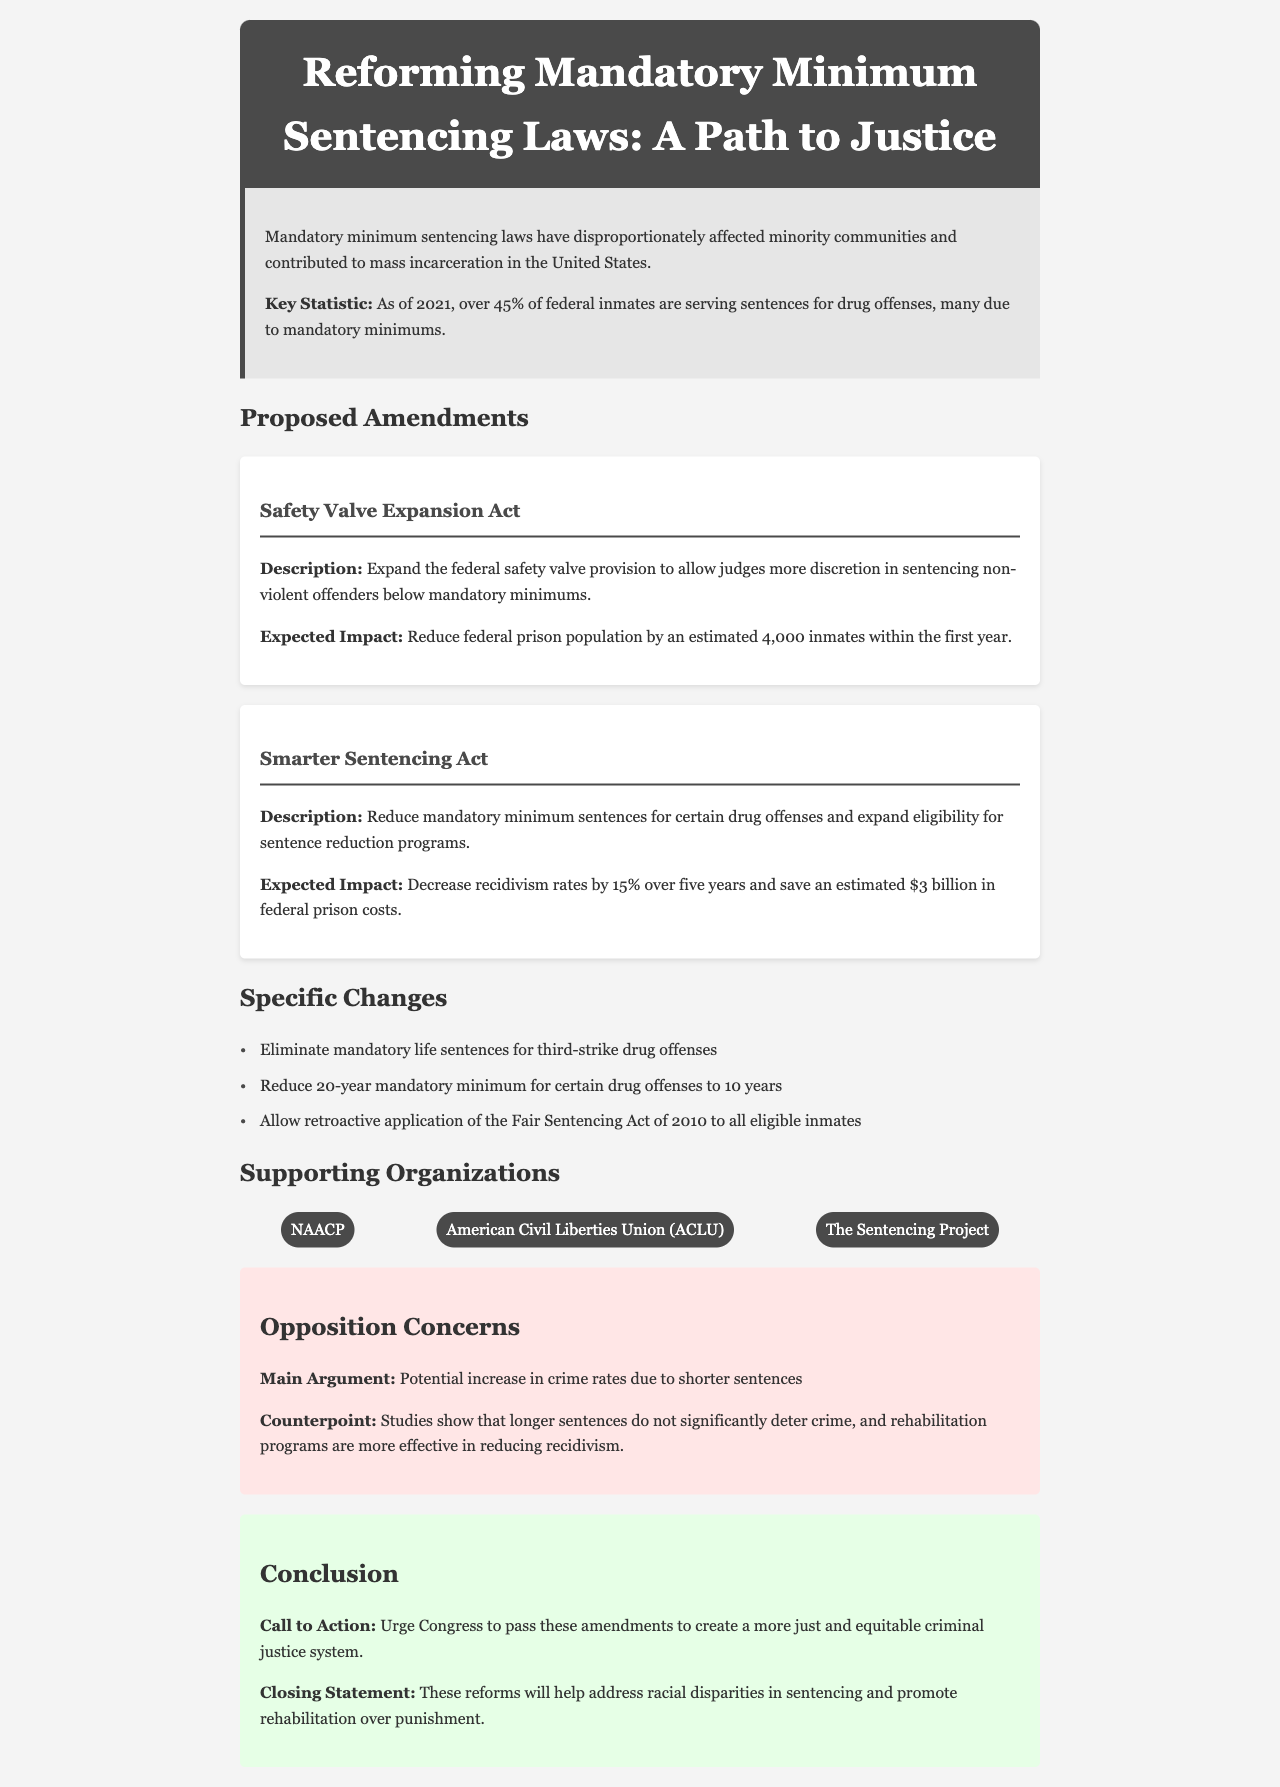What is the title of the document? The title is presented at the top of the document in the header section.
Answer: Reforming Mandatory Minimum Sentencing Laws: A Path to Justice What is the key statistic mentioned about federal inmates? The document includes a specific statistic within the introductory section regarding federal inmates and drug offenses.
Answer: Over 45% of federal inmates are serving sentences for drug offenses What is the expected impact of the Safety Valve Expansion Act? The expected impact is detailed in the description of the proposed amendment concerning the Safety Valve Expansion Act.
Answer: Reduce federal prison population by an estimated 4,000 inmates within the first year Which organization is mentioned as a supporter of the proposed amendments? The supporting organizations are listed in a specific section of the document.
Answer: NAACP What is the main argument of the opposition to the proposed amendments? The main argument is summarized in the opposition section of the document.
Answer: Potential increase in crime rates due to shorter sentences How much is estimated to be saved in federal prison costs with the Smarter Sentencing Act? This information is specified under the expected impact section for the Smarter Sentencing Act.
Answer: $3 billion What specific change involves retroactive application? The specific change regarding retroactive application is listed among the section of specific changes.
Answer: Fair Sentencing Act of 2010 What is the call to action in the conclusion? The call to action is clearly stated in the conclusion of the document.
Answer: Urge Congress to pass these amendments 